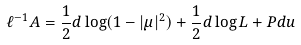<formula> <loc_0><loc_0><loc_500><loc_500>\ell ^ { - 1 } A = { \frac { 1 } { 2 } } d \log ( 1 - | \mu | ^ { 2 } ) + { \frac { 1 } { 2 } } d \log L + P d u</formula> 